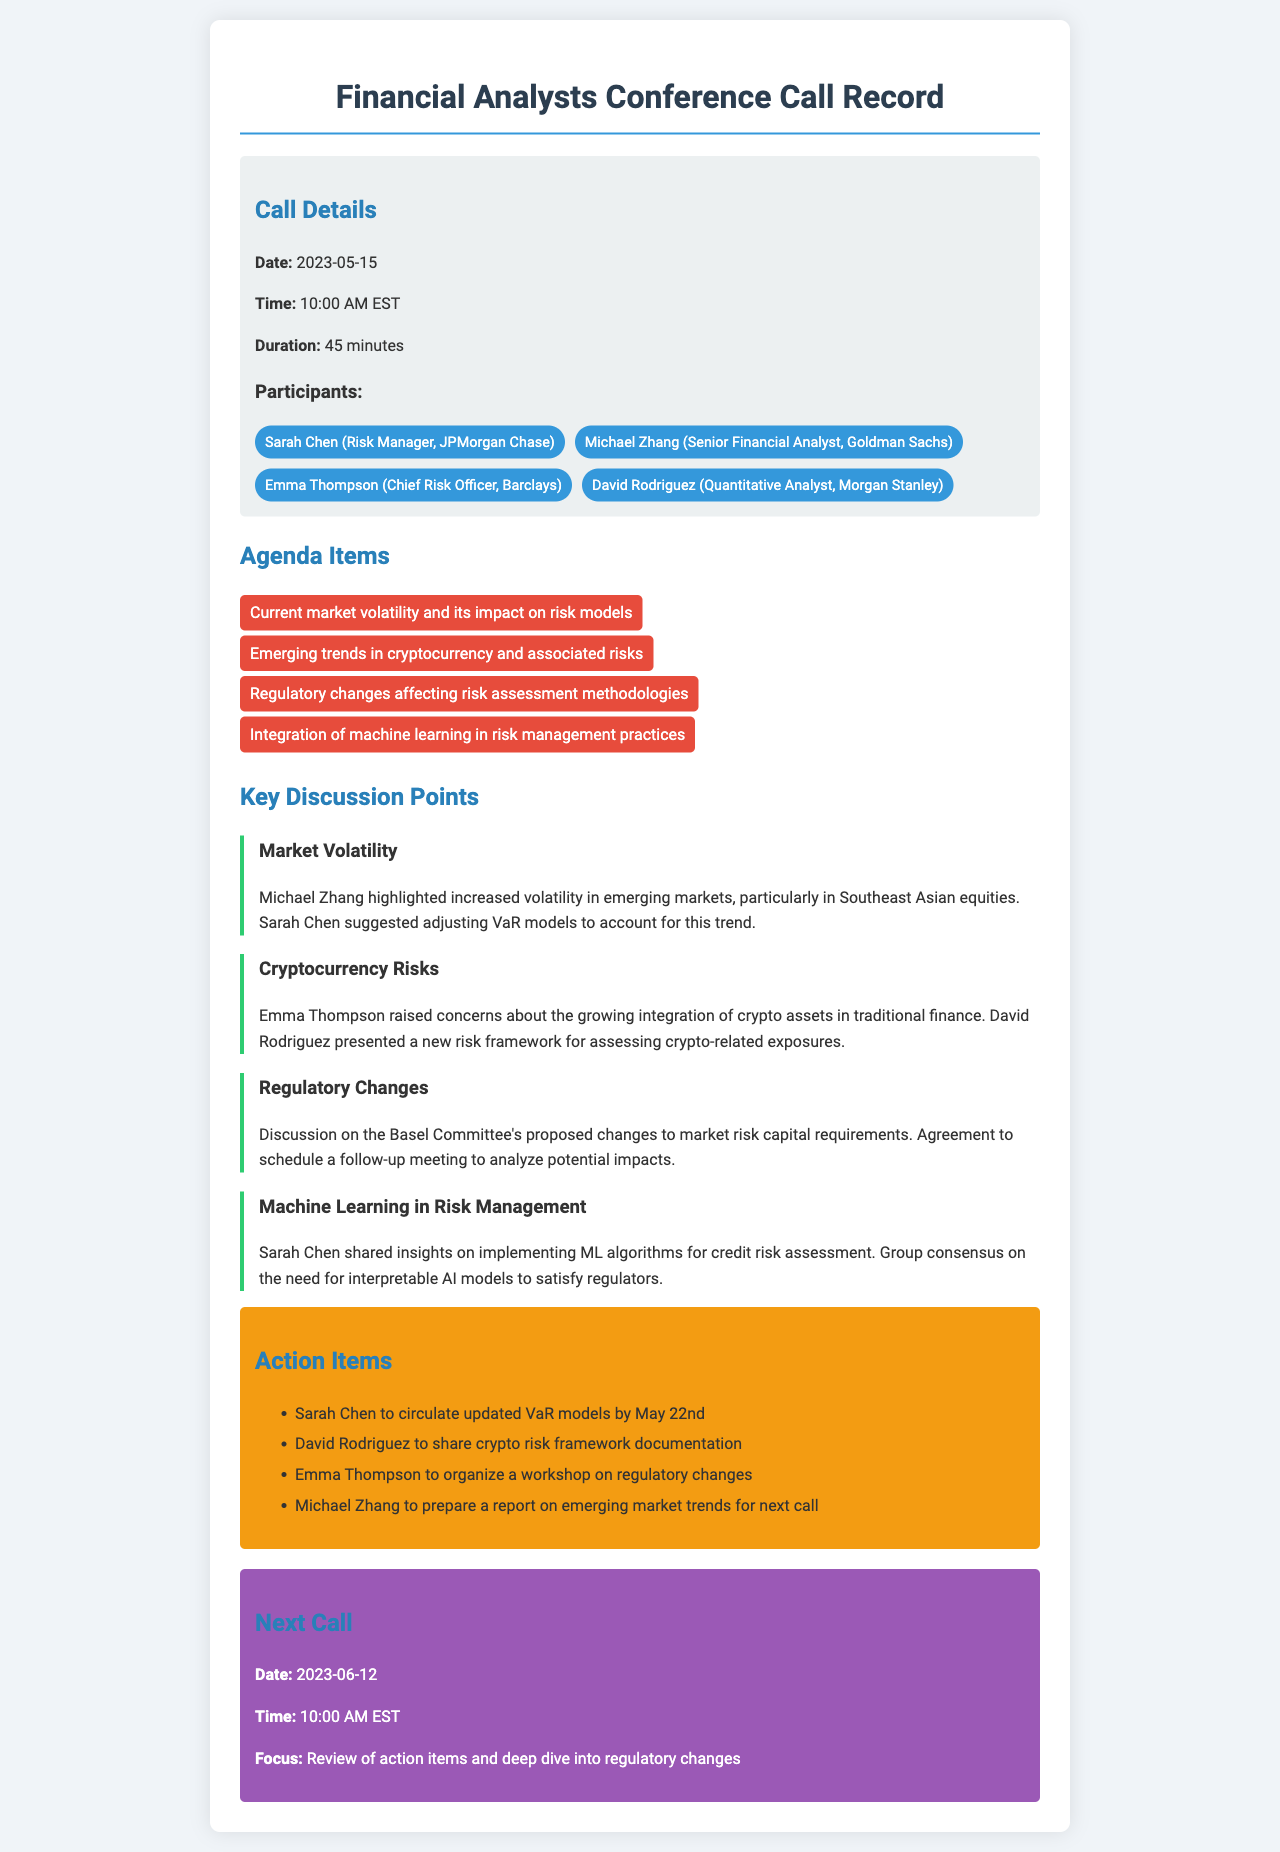What is the date of the conference call? The date of the call is specifically mentioned in the call details section.
Answer: 2023-05-15 Who is the Chief Risk Officer in the call? The participants section lists Emma Thompson as the Chief Risk Officer.
Answer: Emma Thompson What was one agenda item discussed during the call? The agenda items are clearly listed, and any one of them can be an answer.
Answer: Current market volatility and its impact on risk models Which participant discussed integrating machine learning in risk management? The specific discussion points link participants to their respective topics.
Answer: Sarah Chen When is the next call scheduled? The next call details are provided at the end of the document.
Answer: 2023-06-12 What is one action item assigned to David Rodriguez? The action items outline specific tasks assigned to participants.
Answer: Share crypto risk framework documentation What was a key concern raised by Emma Thompson? The section on cryptocurrency risks summarizes Emma's concerns during the discussion.
Answer: Growing integration of crypto assets in traditional finance How many participants were involved in the call? The participant section lists all individuals present.
Answer: Four What is the focus of the next call? The focus of the next call is explicitly stated in the next call section.
Answer: Review of action items and deep dive into regulatory changes 